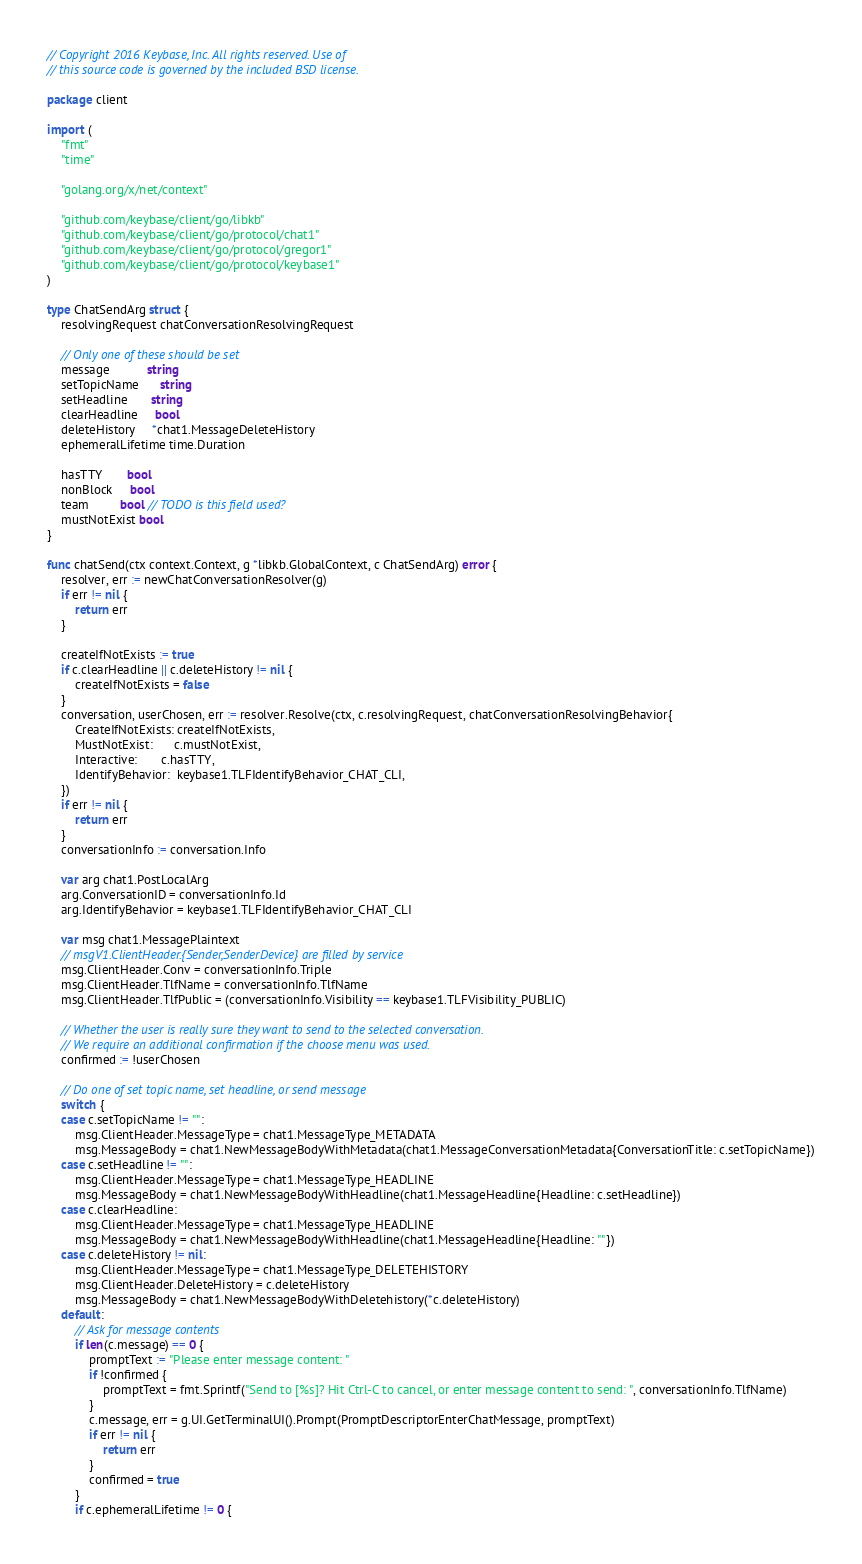<code> <loc_0><loc_0><loc_500><loc_500><_Go_>// Copyright 2016 Keybase, Inc. All rights reserved. Use of
// this source code is governed by the included BSD license.

package client

import (
	"fmt"
	"time"

	"golang.org/x/net/context"

	"github.com/keybase/client/go/libkb"
	"github.com/keybase/client/go/protocol/chat1"
	"github.com/keybase/client/go/protocol/gregor1"
	"github.com/keybase/client/go/protocol/keybase1"
)

type ChatSendArg struct {
	resolvingRequest chatConversationResolvingRequest

	// Only one of these should be set
	message           string
	setTopicName      string
	setHeadline       string
	clearHeadline     bool
	deleteHistory     *chat1.MessageDeleteHistory
	ephemeralLifetime time.Duration

	hasTTY       bool
	nonBlock     bool
	team         bool // TODO is this field used?
	mustNotExist bool
}

func chatSend(ctx context.Context, g *libkb.GlobalContext, c ChatSendArg) error {
	resolver, err := newChatConversationResolver(g)
	if err != nil {
		return err
	}

	createIfNotExists := true
	if c.clearHeadline || c.deleteHistory != nil {
		createIfNotExists = false
	}
	conversation, userChosen, err := resolver.Resolve(ctx, c.resolvingRequest, chatConversationResolvingBehavior{
		CreateIfNotExists: createIfNotExists,
		MustNotExist:      c.mustNotExist,
		Interactive:       c.hasTTY,
		IdentifyBehavior:  keybase1.TLFIdentifyBehavior_CHAT_CLI,
	})
	if err != nil {
		return err
	}
	conversationInfo := conversation.Info

	var arg chat1.PostLocalArg
	arg.ConversationID = conversationInfo.Id
	arg.IdentifyBehavior = keybase1.TLFIdentifyBehavior_CHAT_CLI

	var msg chat1.MessagePlaintext
	// msgV1.ClientHeader.{Sender,SenderDevice} are filled by service
	msg.ClientHeader.Conv = conversationInfo.Triple
	msg.ClientHeader.TlfName = conversationInfo.TlfName
	msg.ClientHeader.TlfPublic = (conversationInfo.Visibility == keybase1.TLFVisibility_PUBLIC)

	// Whether the user is really sure they want to send to the selected conversation.
	// We require an additional confirmation if the choose menu was used.
	confirmed := !userChosen

	// Do one of set topic name, set headline, or send message
	switch {
	case c.setTopicName != "":
		msg.ClientHeader.MessageType = chat1.MessageType_METADATA
		msg.MessageBody = chat1.NewMessageBodyWithMetadata(chat1.MessageConversationMetadata{ConversationTitle: c.setTopicName})
	case c.setHeadline != "":
		msg.ClientHeader.MessageType = chat1.MessageType_HEADLINE
		msg.MessageBody = chat1.NewMessageBodyWithHeadline(chat1.MessageHeadline{Headline: c.setHeadline})
	case c.clearHeadline:
		msg.ClientHeader.MessageType = chat1.MessageType_HEADLINE
		msg.MessageBody = chat1.NewMessageBodyWithHeadline(chat1.MessageHeadline{Headline: ""})
	case c.deleteHistory != nil:
		msg.ClientHeader.MessageType = chat1.MessageType_DELETEHISTORY
		msg.ClientHeader.DeleteHistory = c.deleteHistory
		msg.MessageBody = chat1.NewMessageBodyWithDeletehistory(*c.deleteHistory)
	default:
		// Ask for message contents
		if len(c.message) == 0 {
			promptText := "Please enter message content: "
			if !confirmed {
				promptText = fmt.Sprintf("Send to [%s]? Hit Ctrl-C to cancel, or enter message content to send: ", conversationInfo.TlfName)
			}
			c.message, err = g.UI.GetTerminalUI().Prompt(PromptDescriptorEnterChatMessage, promptText)
			if err != nil {
				return err
			}
			confirmed = true
		}
		if c.ephemeralLifetime != 0 {</code> 